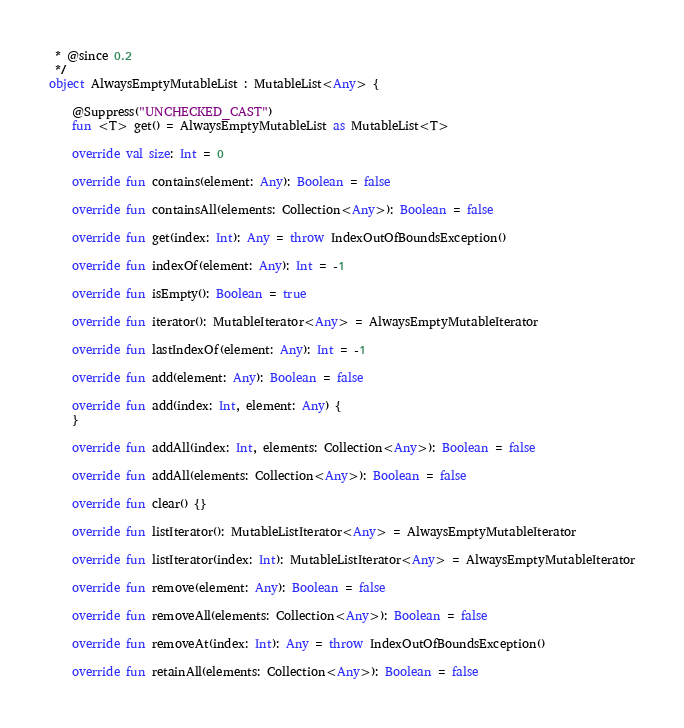Convert code to text. <code><loc_0><loc_0><loc_500><loc_500><_Kotlin_> * @since 0.2
 */
object AlwaysEmptyMutableList : MutableList<Any> {

	@Suppress("UNCHECKED_CAST")
	fun <T> get() = AlwaysEmptyMutableList as MutableList<T>

	override val size: Int = 0

	override fun contains(element: Any): Boolean = false

	override fun containsAll(elements: Collection<Any>): Boolean = false

	override fun get(index: Int): Any = throw IndexOutOfBoundsException()

	override fun indexOf(element: Any): Int = -1

	override fun isEmpty(): Boolean = true

	override fun iterator(): MutableIterator<Any> = AlwaysEmptyMutableIterator

	override fun lastIndexOf(element: Any): Int = -1

	override fun add(element: Any): Boolean = false

	override fun add(index: Int, element: Any) {
	}

	override fun addAll(index: Int, elements: Collection<Any>): Boolean = false

	override fun addAll(elements: Collection<Any>): Boolean = false

	override fun clear() {}

	override fun listIterator(): MutableListIterator<Any> = AlwaysEmptyMutableIterator

	override fun listIterator(index: Int): MutableListIterator<Any> = AlwaysEmptyMutableIterator

	override fun remove(element: Any): Boolean = false

	override fun removeAll(elements: Collection<Any>): Boolean = false

	override fun removeAt(index: Int): Any = throw IndexOutOfBoundsException()

	override fun retainAll(elements: Collection<Any>): Boolean = false
</code> 